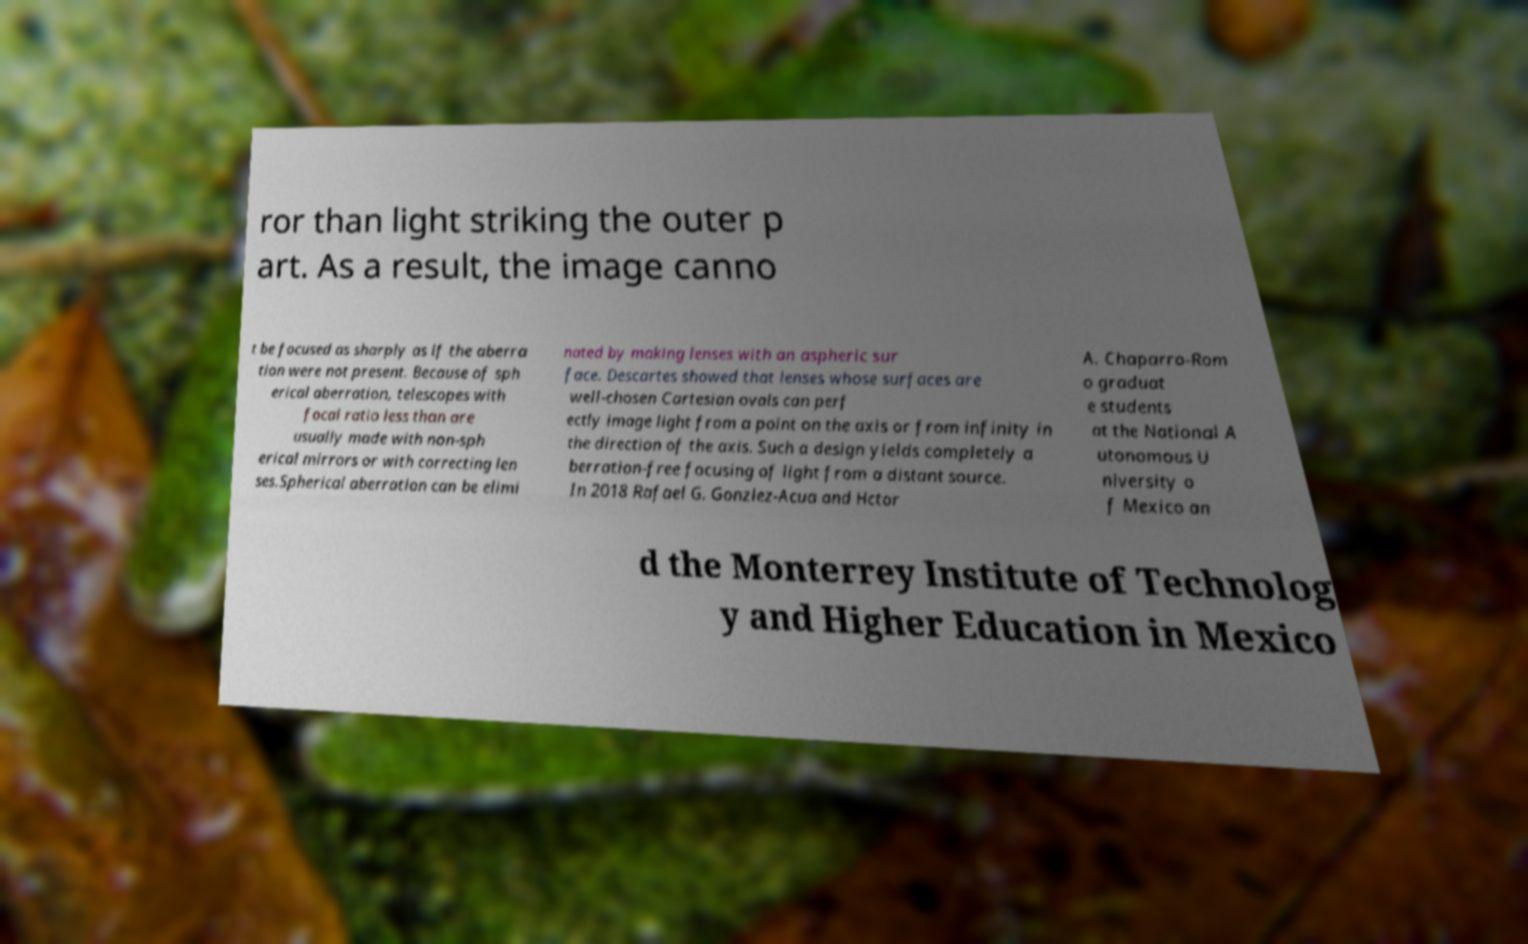What messages or text are displayed in this image? I need them in a readable, typed format. ror than light striking the outer p art. As a result, the image canno t be focused as sharply as if the aberra tion were not present. Because of sph erical aberration, telescopes with focal ratio less than are usually made with non-sph erical mirrors or with correcting len ses.Spherical aberration can be elimi nated by making lenses with an aspheric sur face. Descartes showed that lenses whose surfaces are well-chosen Cartesian ovals can perf ectly image light from a point on the axis or from infinity in the direction of the axis. Such a design yields completely a berration-free focusing of light from a distant source. In 2018 Rafael G. Gonzlez-Acua and Hctor A. Chaparro-Rom o graduat e students at the National A utonomous U niversity o f Mexico an d the Monterrey Institute of Technolog y and Higher Education in Mexico 